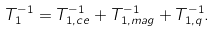Convert formula to latex. <formula><loc_0><loc_0><loc_500><loc_500>T _ { 1 } ^ { - 1 } = T _ { 1 , c e } ^ { - 1 } + T _ { 1 , m a g } ^ { - 1 } + T _ { 1 , q } ^ { - 1 } .</formula> 